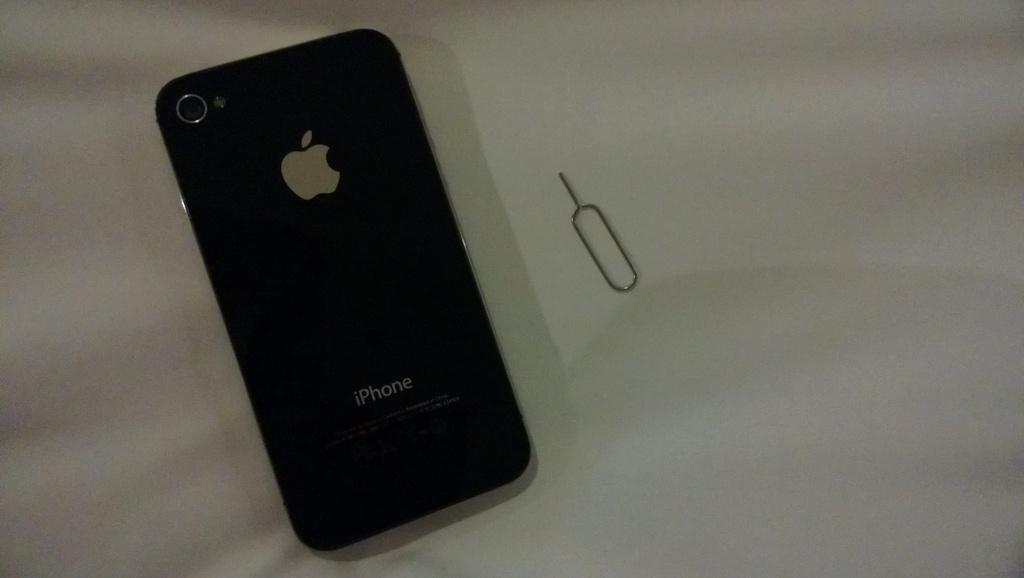<image>
Relay a brief, clear account of the picture shown. The back of a black iPhone case next to a small object 